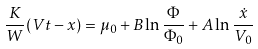Convert formula to latex. <formula><loc_0><loc_0><loc_500><loc_500>\frac { K } { W } ( V t - x ) = \mu _ { 0 } + B \ln \frac { \Phi } { \Phi _ { 0 } } + A \ln \frac { \dot { x } } { V _ { 0 } }</formula> 